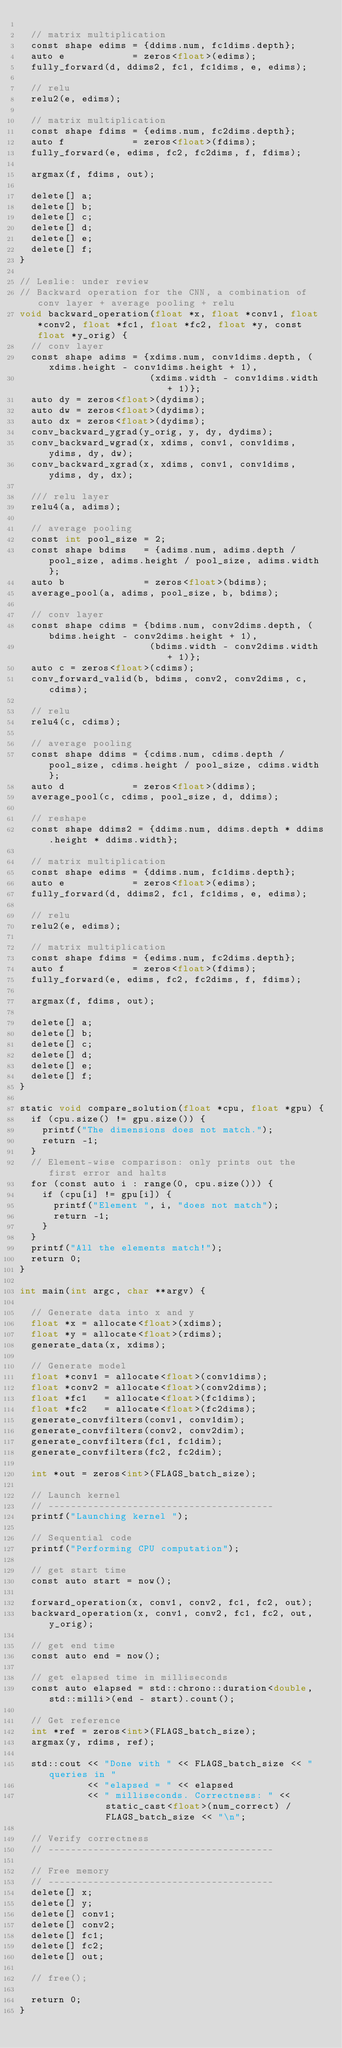<code> <loc_0><loc_0><loc_500><loc_500><_Cuda_>
  // matrix multiplication
  const shape edims = {ddims.num, fc1dims.depth};
  auto e            = zeros<float>(edims);
  fully_forward(d, ddims2, fc1, fc1dims, e, edims);

  // relu
  relu2(e, edims);

  // matrix multiplication
  const shape fdims = {edims.num, fc2dims.depth};
  auto f            = zeros<float>(fdims);
  fully_forward(e, edims, fc2, fc2dims, f, fdims);

  argmax(f, fdims, out);

  delete[] a;
  delete[] b;
  delete[] c;
  delete[] d;
  delete[] e;
  delete[] f;
}

// Leslie: under review
// Backward operation for the CNN, a combination of conv layer + average pooling + relu
void backward_operation(float *x, float *conv1, float *conv2, float *fc1, float *fc2, float *y, const float *y_orig) {
  // conv layer
  const shape adims = {xdims.num, conv1dims.depth, (xdims.height - conv1dims.height + 1),
                       (xdims.width - conv1dims.width + 1)};
  auto dy = zeros<float>(dydims);
  auto dw = zeros<float>(dydims);
  auto dx = zeros<float>(dydims);
  conv_backward_ygrad(y_orig, y, dy, dydims);
  conv_backward_wgrad(x, xdims, conv1, conv1dims, ydims, dy, dw);
  conv_backward_xgrad(x, xdims, conv1, conv1dims, ydims, dy, dx);

  /// relu layer
  relu4(a, adims);

  // average pooling
  const int pool_size = 2;
  const shape bdims   = {adims.num, adims.depth / pool_size, adims.height / pool_size, adims.width};
  auto b              = zeros<float>(bdims);
  average_pool(a, adims, pool_size, b, bdims);

  // conv layer
  const shape cdims = {bdims.num, conv2dims.depth, (bdims.height - conv2dims.height + 1),
                       (bdims.width - conv2dims.width + 1)};
  auto c = zeros<float>(cdims);
  conv_forward_valid(b, bdims, conv2, conv2dims, c, cdims);

  // relu
  relu4(c, cdims);

  // average pooling
  const shape ddims = {cdims.num, cdims.depth / pool_size, cdims.height / pool_size, cdims.width};
  auto d            = zeros<float>(ddims);
  average_pool(c, cdims, pool_size, d, ddims);

  // reshape
  const shape ddims2 = {ddims.num, ddims.depth * ddims.height * ddims.width};

  // matrix multiplication
  const shape edims = {ddims.num, fc1dims.depth};
  auto e            = zeros<float>(edims);
  fully_forward(d, ddims2, fc1, fc1dims, e, edims);

  // relu
  relu2(e, edims);

  // matrix multiplication
  const shape fdims = {edims.num, fc2dims.depth};
  auto f            = zeros<float>(fdims);
  fully_forward(e, edims, fc2, fc2dims, f, fdims);

  argmax(f, fdims, out);

  delete[] a;
  delete[] b;
  delete[] c;
  delete[] d;
  delete[] e;
  delete[] f;
}

static void compare_solution(float *cpu, float *gpu) {
  if (cpu.size() != gpu.size()) {
    printf("The dimensions does not match.");
    return -1;
  }
  // Element-wise comparison: only prints out the first error and halts
  for (const auto i : range(0, cpu.size())) {
    if (cpu[i] != gpu[i]) {
      printf("Element ", i, "does not match");
      return -1;
    }
  }
  printf("All the elements match!");
  return 0;
}

int main(int argc, char **argv) {

  // Generate data into x and y
  float *x = allocate<float>(xdims);
  float *y = allocate<float>(rdims);
  generate_data(x, xdims);

  // Generate model
  float *conv1 = allocate<float>(conv1dims);
  float *conv2 = allocate<float>(conv2dims);
  float *fc1   = allocate<float>(fc1dims);
  float *fc2   = allocate<float>(fc2dims);
  generate_convfilters(conv1, conv1dim);
  generate_convfilters(conv2, conv2dim);
  generate_convfilters(fc1, fc1dim);
  generate_convfilters(fc2, fc2dim);

  int *out = zeros<int>(FLAGS_batch_size);

  // Launch kernel
  // ----------------------------------------
  printf("Launching kernel ");

  // Sequential code
  printf("Performing CPU computation");

  // get start time
  const auto start = now();

  forward_operation(x, conv1, conv2, fc1, fc2, out);
  backward_operation(x, conv1, conv2, fc1, fc2, out, y_orig);

  // get end time
  const auto end = now();

  // get elapsed time in milliseconds
  const auto elapsed = std::chrono::duration<double, std::milli>(end - start).count();

  // Get reference
  int *ref = zeros<int>(FLAGS_batch_size);
  argmax(y, rdims, ref);

  std::cout << "Done with " << FLAGS_batch_size << " queries in "
            << "elapsed = " << elapsed
            << " milliseconds. Correctness: " << static_cast<float>(num_correct) / FLAGS_batch_size << "\n";

  // Verify correctness
  // ----------------------------------------

  // Free memory
  // ----------------------------------------
  delete[] x;
  delete[] y;
  delete[] conv1;
  delete[] conv2;
  delete[] fc1;
  delete[] fc2;
  delete[] out;

  // free();

  return 0;
}
</code> 